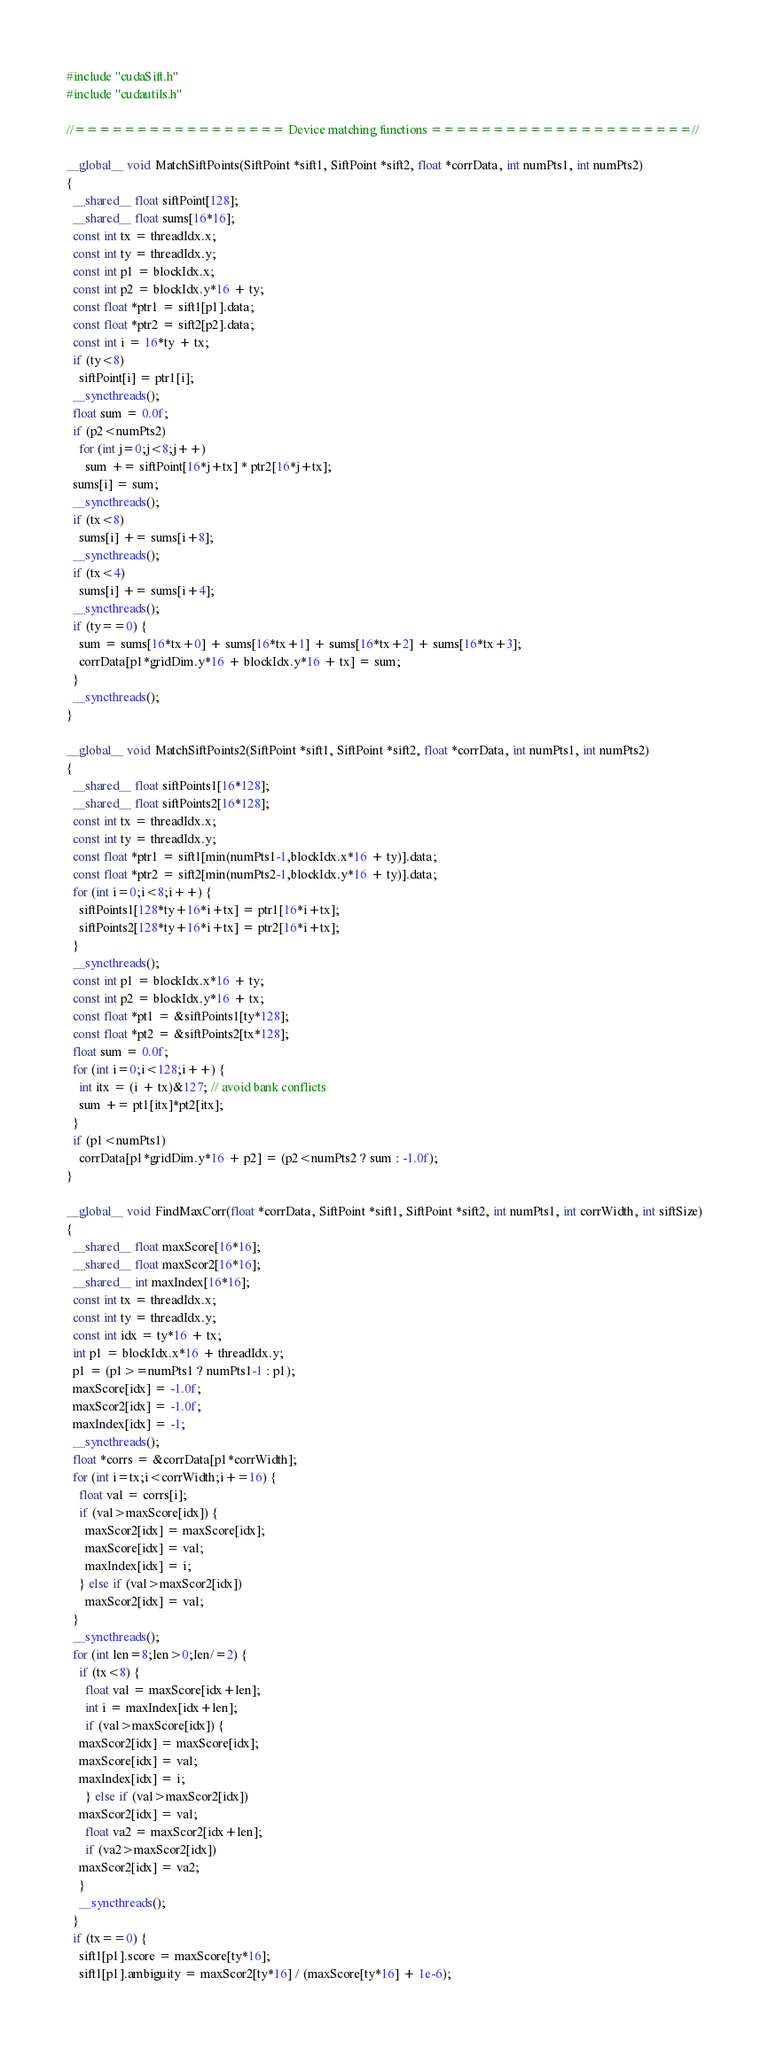<code> <loc_0><loc_0><loc_500><loc_500><_Cuda_>#include "cudaSift.h"
#include "cudautils.h"

//================= Device matching functions =====================//

__global__ void MatchSiftPoints(SiftPoint *sift1, SiftPoint *sift2, float *corrData, int numPts1, int numPts2)
{
  __shared__ float siftPoint[128];
  __shared__ float sums[16*16];
  const int tx = threadIdx.x;
  const int ty = threadIdx.y;
  const int p1 = blockIdx.x;
  const int p2 = blockIdx.y*16 + ty;
  const float *ptr1 = sift1[p1].data;
  const float *ptr2 = sift2[p2].data;
  const int i = 16*ty + tx;
  if (ty<8)
    siftPoint[i] = ptr1[i];
  __syncthreads();
  float sum = 0.0f;
  if (p2<numPts2)
    for (int j=0;j<8;j++)
      sum += siftPoint[16*j+tx] * ptr2[16*j+tx];
  sums[i] = sum;
  __syncthreads();
  if (tx<8)
    sums[i] += sums[i+8];
  __syncthreads();
  if (tx<4)
    sums[i] += sums[i+4];
  __syncthreads();
  if (ty==0) {
    sum = sums[16*tx+0] + sums[16*tx+1] + sums[16*tx+2] + sums[16*tx+3];
    corrData[p1*gridDim.y*16 + blockIdx.y*16 + tx] = sum;
  }
  __syncthreads();
}

__global__ void MatchSiftPoints2(SiftPoint *sift1, SiftPoint *sift2, float *corrData, int numPts1, int numPts2)
{
  __shared__ float siftPoints1[16*128];
  __shared__ float siftPoints2[16*128];
  const int tx = threadIdx.x;
  const int ty = threadIdx.y;
  const float *ptr1 = sift1[min(numPts1-1,blockIdx.x*16 + ty)].data;
  const float *ptr2 = sift2[min(numPts2-1,blockIdx.y*16 + ty)].data;
  for (int i=0;i<8;i++) {
    siftPoints1[128*ty+16*i+tx] = ptr1[16*i+tx];
    siftPoints2[128*ty+16*i+tx] = ptr2[16*i+tx];
  }
  __syncthreads();
  const int p1 = blockIdx.x*16 + ty;
  const int p2 = blockIdx.y*16 + tx;
  const float *pt1 = &siftPoints1[ty*128];
  const float *pt2 = &siftPoints2[tx*128];
  float sum = 0.0f;
  for (int i=0;i<128;i++) {
    int itx = (i + tx)&127; // avoid bank conflicts
    sum += pt1[itx]*pt2[itx];
  }
  if (p1<numPts1)
    corrData[p1*gridDim.y*16 + p2] = (p2<numPts2 ? sum : -1.0f);
}

__global__ void FindMaxCorr(float *corrData, SiftPoint *sift1, SiftPoint *sift2, int numPts1, int corrWidth, int siftSize)
{
  __shared__ float maxScore[16*16];
  __shared__ float maxScor2[16*16];
  __shared__ int maxIndex[16*16];
  const int tx = threadIdx.x;
  const int ty = threadIdx.y;
  const int idx = ty*16 + tx;
  int p1 = blockIdx.x*16 + threadIdx.y;
  p1 = (p1>=numPts1 ? numPts1-1 : p1);
  maxScore[idx] = -1.0f;
  maxScor2[idx] = -1.0f;
  maxIndex[idx] = -1;
  __syncthreads();
  float *corrs = &corrData[p1*corrWidth];
  for (int i=tx;i<corrWidth;i+=16) {
    float val = corrs[i];
    if (val>maxScore[idx]) {
      maxScor2[idx] = maxScore[idx];
      maxScore[idx] = val;
      maxIndex[idx] = i;
    } else if (val>maxScor2[idx])
      maxScor2[idx] = val;
  }
  __syncthreads();
  for (int len=8;len>0;len/=2) {
    if (tx<8) {
      float val = maxScore[idx+len];
      int i = maxIndex[idx+len];
      if (val>maxScore[idx]) {
	maxScor2[idx] = maxScore[idx];
	maxScore[idx] = val;
	maxIndex[idx] = i;
      } else if (val>maxScor2[idx])
	maxScor2[idx] = val;
      float va2 = maxScor2[idx+len];
      if (va2>maxScor2[idx])
	maxScor2[idx] = va2;
    }
    __syncthreads();
  }
  if (tx==0) {
    sift1[p1].score = maxScore[ty*16];
    sift1[p1].ambiguity = maxScor2[ty*16] / (maxScore[ty*16] + 1e-6);</code> 